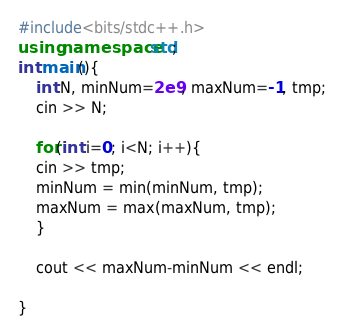Convert code to text. <code><loc_0><loc_0><loc_500><loc_500><_C++_>#include<bits/stdc++.h>
using namespace std;
int main(){
    int N, minNum=2e9, maxNum=-1, tmp;
    cin >> N;
    
    for(int i=0; i<N; i++){
	cin >> tmp;
	minNum = min(minNum, tmp);
	maxNum = max(maxNum, tmp);
    }

    cout << maxNum-minNum << endl;

}
</code> 